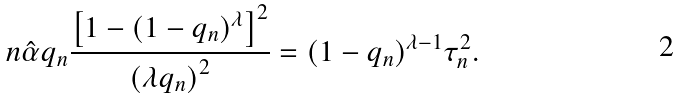Convert formula to latex. <formula><loc_0><loc_0><loc_500><loc_500>n \hat { \alpha } q _ { n } \frac { \left [ 1 - ( 1 - q _ { n } ) ^ { \lambda } \right ] ^ { 2 } } { \left ( \lambda q _ { n } \right ) ^ { 2 } } = ( 1 - q _ { n } ) ^ { \lambda - 1 } \tau _ { n } ^ { 2 } .</formula> 